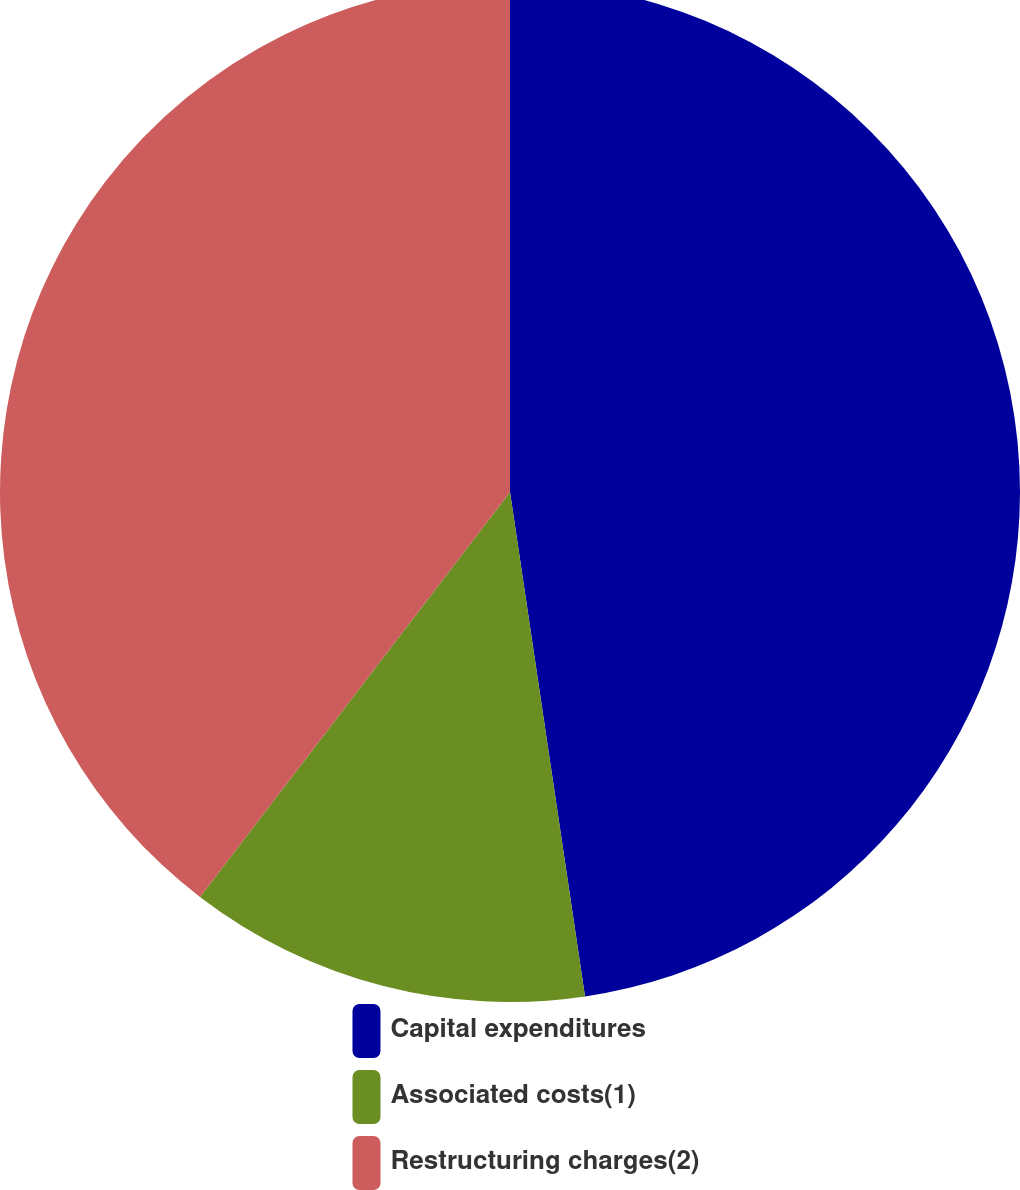Convert chart. <chart><loc_0><loc_0><loc_500><loc_500><pie_chart><fcel>Capital expenditures<fcel>Associated costs(1)<fcel>Restructuring charges(2)<nl><fcel>47.65%<fcel>12.75%<fcel>39.6%<nl></chart> 